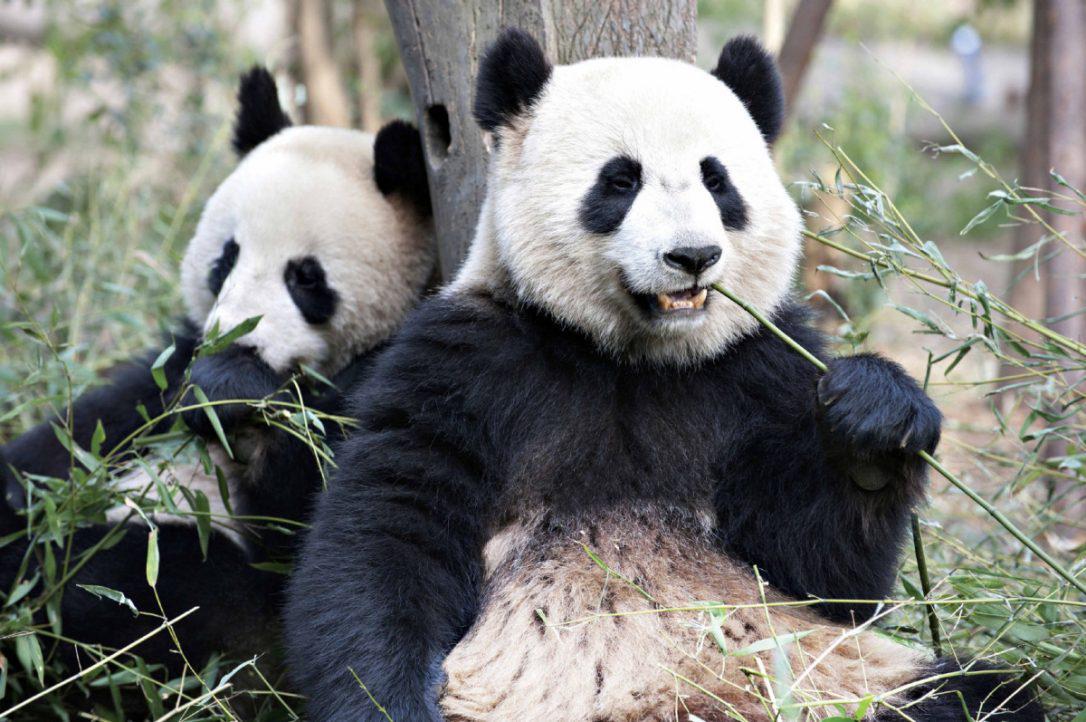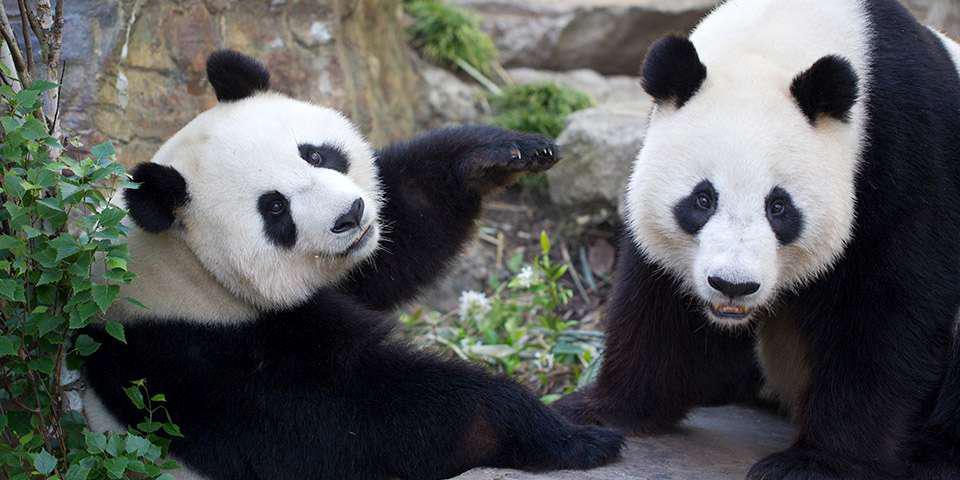The first image is the image on the left, the second image is the image on the right. Assess this claim about the two images: "The two pandas in the image on the left are eating bamboo shoots.". Correct or not? Answer yes or no. Yes. The first image is the image on the left, the second image is the image on the right. Assess this claim about the two images: "Two pandas are face-to-face, one with its front paws touching the other, in the right image.". Correct or not? Answer yes or no. No. 